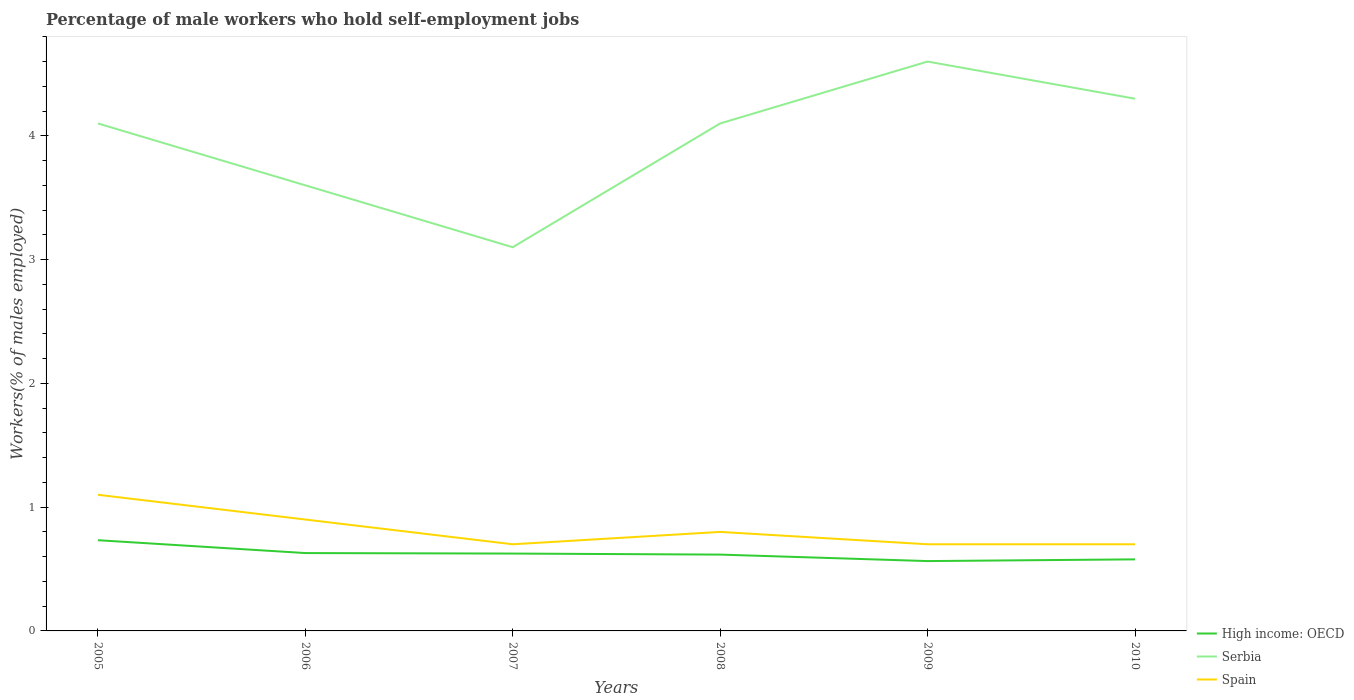How many different coloured lines are there?
Ensure brevity in your answer.  3. Does the line corresponding to Serbia intersect with the line corresponding to Spain?
Keep it short and to the point. No. Across all years, what is the maximum percentage of self-employed male workers in High income: OECD?
Your answer should be compact. 0.56. In which year was the percentage of self-employed male workers in High income: OECD maximum?
Offer a very short reply. 2009. What is the total percentage of self-employed male workers in Serbia in the graph?
Make the answer very short. -0.5. What is the difference between the highest and the second highest percentage of self-employed male workers in Spain?
Give a very brief answer. 0.4. What is the difference between the highest and the lowest percentage of self-employed male workers in High income: OECD?
Make the answer very short. 3. How many lines are there?
Your answer should be very brief. 3. What is the difference between two consecutive major ticks on the Y-axis?
Give a very brief answer. 1. Are the values on the major ticks of Y-axis written in scientific E-notation?
Provide a short and direct response. No. Does the graph contain any zero values?
Offer a very short reply. No. How many legend labels are there?
Make the answer very short. 3. What is the title of the graph?
Your answer should be very brief. Percentage of male workers who hold self-employment jobs. What is the label or title of the X-axis?
Keep it short and to the point. Years. What is the label or title of the Y-axis?
Offer a very short reply. Workers(% of males employed). What is the Workers(% of males employed) of High income: OECD in 2005?
Your answer should be compact. 0.73. What is the Workers(% of males employed) in Serbia in 2005?
Give a very brief answer. 4.1. What is the Workers(% of males employed) of Spain in 2005?
Provide a short and direct response. 1.1. What is the Workers(% of males employed) in High income: OECD in 2006?
Your answer should be very brief. 0.63. What is the Workers(% of males employed) in Serbia in 2006?
Offer a very short reply. 3.6. What is the Workers(% of males employed) in Spain in 2006?
Offer a very short reply. 0.9. What is the Workers(% of males employed) in High income: OECD in 2007?
Your answer should be compact. 0.62. What is the Workers(% of males employed) of Serbia in 2007?
Ensure brevity in your answer.  3.1. What is the Workers(% of males employed) of Spain in 2007?
Your response must be concise. 0.7. What is the Workers(% of males employed) in High income: OECD in 2008?
Your answer should be compact. 0.62. What is the Workers(% of males employed) of Serbia in 2008?
Make the answer very short. 4.1. What is the Workers(% of males employed) of Spain in 2008?
Provide a short and direct response. 0.8. What is the Workers(% of males employed) of High income: OECD in 2009?
Your answer should be very brief. 0.56. What is the Workers(% of males employed) in Serbia in 2009?
Offer a terse response. 4.6. What is the Workers(% of males employed) of Spain in 2009?
Your answer should be compact. 0.7. What is the Workers(% of males employed) of High income: OECD in 2010?
Ensure brevity in your answer.  0.58. What is the Workers(% of males employed) in Serbia in 2010?
Provide a short and direct response. 4.3. What is the Workers(% of males employed) of Spain in 2010?
Make the answer very short. 0.7. Across all years, what is the maximum Workers(% of males employed) in High income: OECD?
Your answer should be compact. 0.73. Across all years, what is the maximum Workers(% of males employed) in Serbia?
Your answer should be very brief. 4.6. Across all years, what is the maximum Workers(% of males employed) of Spain?
Give a very brief answer. 1.1. Across all years, what is the minimum Workers(% of males employed) of High income: OECD?
Offer a terse response. 0.56. Across all years, what is the minimum Workers(% of males employed) in Serbia?
Your response must be concise. 3.1. Across all years, what is the minimum Workers(% of males employed) in Spain?
Make the answer very short. 0.7. What is the total Workers(% of males employed) of High income: OECD in the graph?
Your answer should be compact. 3.75. What is the total Workers(% of males employed) in Serbia in the graph?
Offer a terse response. 23.8. What is the total Workers(% of males employed) in Spain in the graph?
Make the answer very short. 4.9. What is the difference between the Workers(% of males employed) in High income: OECD in 2005 and that in 2006?
Give a very brief answer. 0.1. What is the difference between the Workers(% of males employed) of Serbia in 2005 and that in 2006?
Your answer should be compact. 0.5. What is the difference between the Workers(% of males employed) of High income: OECD in 2005 and that in 2007?
Your answer should be very brief. 0.11. What is the difference between the Workers(% of males employed) of Serbia in 2005 and that in 2007?
Your answer should be very brief. 1. What is the difference between the Workers(% of males employed) in Spain in 2005 and that in 2007?
Give a very brief answer. 0.4. What is the difference between the Workers(% of males employed) of High income: OECD in 2005 and that in 2008?
Your answer should be very brief. 0.12. What is the difference between the Workers(% of males employed) of High income: OECD in 2005 and that in 2009?
Keep it short and to the point. 0.17. What is the difference between the Workers(% of males employed) in Serbia in 2005 and that in 2009?
Keep it short and to the point. -0.5. What is the difference between the Workers(% of males employed) in Spain in 2005 and that in 2009?
Offer a very short reply. 0.4. What is the difference between the Workers(% of males employed) in High income: OECD in 2005 and that in 2010?
Your response must be concise. 0.15. What is the difference between the Workers(% of males employed) in Spain in 2005 and that in 2010?
Offer a terse response. 0.4. What is the difference between the Workers(% of males employed) in High income: OECD in 2006 and that in 2007?
Offer a terse response. 0. What is the difference between the Workers(% of males employed) of Serbia in 2006 and that in 2007?
Offer a very short reply. 0.5. What is the difference between the Workers(% of males employed) in High income: OECD in 2006 and that in 2008?
Your answer should be very brief. 0.01. What is the difference between the Workers(% of males employed) in Serbia in 2006 and that in 2008?
Provide a short and direct response. -0.5. What is the difference between the Workers(% of males employed) of Spain in 2006 and that in 2008?
Give a very brief answer. 0.1. What is the difference between the Workers(% of males employed) of High income: OECD in 2006 and that in 2009?
Offer a terse response. 0.06. What is the difference between the Workers(% of males employed) in Serbia in 2006 and that in 2009?
Give a very brief answer. -1. What is the difference between the Workers(% of males employed) in Spain in 2006 and that in 2009?
Provide a succinct answer. 0.2. What is the difference between the Workers(% of males employed) in High income: OECD in 2006 and that in 2010?
Your answer should be compact. 0.05. What is the difference between the Workers(% of males employed) in High income: OECD in 2007 and that in 2008?
Provide a short and direct response. 0.01. What is the difference between the Workers(% of males employed) of Serbia in 2007 and that in 2008?
Your answer should be compact. -1. What is the difference between the Workers(% of males employed) in High income: OECD in 2007 and that in 2009?
Provide a succinct answer. 0.06. What is the difference between the Workers(% of males employed) in Serbia in 2007 and that in 2009?
Give a very brief answer. -1.5. What is the difference between the Workers(% of males employed) in High income: OECD in 2007 and that in 2010?
Provide a short and direct response. 0.05. What is the difference between the Workers(% of males employed) in Serbia in 2007 and that in 2010?
Make the answer very short. -1.2. What is the difference between the Workers(% of males employed) in Spain in 2007 and that in 2010?
Offer a terse response. 0. What is the difference between the Workers(% of males employed) of High income: OECD in 2008 and that in 2009?
Keep it short and to the point. 0.05. What is the difference between the Workers(% of males employed) in Serbia in 2008 and that in 2009?
Your answer should be very brief. -0.5. What is the difference between the Workers(% of males employed) of Spain in 2008 and that in 2009?
Your answer should be very brief. 0.1. What is the difference between the Workers(% of males employed) in High income: OECD in 2008 and that in 2010?
Give a very brief answer. 0.04. What is the difference between the Workers(% of males employed) of Spain in 2008 and that in 2010?
Provide a short and direct response. 0.1. What is the difference between the Workers(% of males employed) of High income: OECD in 2009 and that in 2010?
Offer a terse response. -0.01. What is the difference between the Workers(% of males employed) of Serbia in 2009 and that in 2010?
Your answer should be very brief. 0.3. What is the difference between the Workers(% of males employed) of Spain in 2009 and that in 2010?
Make the answer very short. 0. What is the difference between the Workers(% of males employed) of High income: OECD in 2005 and the Workers(% of males employed) of Serbia in 2006?
Your answer should be compact. -2.87. What is the difference between the Workers(% of males employed) of High income: OECD in 2005 and the Workers(% of males employed) of Spain in 2006?
Your response must be concise. -0.17. What is the difference between the Workers(% of males employed) in Serbia in 2005 and the Workers(% of males employed) in Spain in 2006?
Provide a short and direct response. 3.2. What is the difference between the Workers(% of males employed) of High income: OECD in 2005 and the Workers(% of males employed) of Serbia in 2007?
Offer a very short reply. -2.37. What is the difference between the Workers(% of males employed) of High income: OECD in 2005 and the Workers(% of males employed) of Spain in 2007?
Your answer should be compact. 0.03. What is the difference between the Workers(% of males employed) in High income: OECD in 2005 and the Workers(% of males employed) in Serbia in 2008?
Your response must be concise. -3.37. What is the difference between the Workers(% of males employed) in High income: OECD in 2005 and the Workers(% of males employed) in Spain in 2008?
Your response must be concise. -0.07. What is the difference between the Workers(% of males employed) in High income: OECD in 2005 and the Workers(% of males employed) in Serbia in 2009?
Make the answer very short. -3.87. What is the difference between the Workers(% of males employed) in High income: OECD in 2005 and the Workers(% of males employed) in Spain in 2009?
Ensure brevity in your answer.  0.03. What is the difference between the Workers(% of males employed) in Serbia in 2005 and the Workers(% of males employed) in Spain in 2009?
Keep it short and to the point. 3.4. What is the difference between the Workers(% of males employed) of High income: OECD in 2005 and the Workers(% of males employed) of Serbia in 2010?
Provide a succinct answer. -3.57. What is the difference between the Workers(% of males employed) in High income: OECD in 2005 and the Workers(% of males employed) in Spain in 2010?
Your response must be concise. 0.03. What is the difference between the Workers(% of males employed) in Serbia in 2005 and the Workers(% of males employed) in Spain in 2010?
Provide a short and direct response. 3.4. What is the difference between the Workers(% of males employed) of High income: OECD in 2006 and the Workers(% of males employed) of Serbia in 2007?
Your answer should be compact. -2.47. What is the difference between the Workers(% of males employed) of High income: OECD in 2006 and the Workers(% of males employed) of Spain in 2007?
Make the answer very short. -0.07. What is the difference between the Workers(% of males employed) of Serbia in 2006 and the Workers(% of males employed) of Spain in 2007?
Provide a short and direct response. 2.9. What is the difference between the Workers(% of males employed) in High income: OECD in 2006 and the Workers(% of males employed) in Serbia in 2008?
Offer a terse response. -3.47. What is the difference between the Workers(% of males employed) in High income: OECD in 2006 and the Workers(% of males employed) in Spain in 2008?
Your response must be concise. -0.17. What is the difference between the Workers(% of males employed) in Serbia in 2006 and the Workers(% of males employed) in Spain in 2008?
Provide a succinct answer. 2.8. What is the difference between the Workers(% of males employed) of High income: OECD in 2006 and the Workers(% of males employed) of Serbia in 2009?
Your response must be concise. -3.97. What is the difference between the Workers(% of males employed) of High income: OECD in 2006 and the Workers(% of males employed) of Spain in 2009?
Offer a very short reply. -0.07. What is the difference between the Workers(% of males employed) in Serbia in 2006 and the Workers(% of males employed) in Spain in 2009?
Give a very brief answer. 2.9. What is the difference between the Workers(% of males employed) of High income: OECD in 2006 and the Workers(% of males employed) of Serbia in 2010?
Make the answer very short. -3.67. What is the difference between the Workers(% of males employed) of High income: OECD in 2006 and the Workers(% of males employed) of Spain in 2010?
Your answer should be compact. -0.07. What is the difference between the Workers(% of males employed) in Serbia in 2006 and the Workers(% of males employed) in Spain in 2010?
Offer a terse response. 2.9. What is the difference between the Workers(% of males employed) in High income: OECD in 2007 and the Workers(% of males employed) in Serbia in 2008?
Make the answer very short. -3.48. What is the difference between the Workers(% of males employed) of High income: OECD in 2007 and the Workers(% of males employed) of Spain in 2008?
Give a very brief answer. -0.17. What is the difference between the Workers(% of males employed) of Serbia in 2007 and the Workers(% of males employed) of Spain in 2008?
Give a very brief answer. 2.3. What is the difference between the Workers(% of males employed) of High income: OECD in 2007 and the Workers(% of males employed) of Serbia in 2009?
Offer a terse response. -3.98. What is the difference between the Workers(% of males employed) in High income: OECD in 2007 and the Workers(% of males employed) in Spain in 2009?
Give a very brief answer. -0.07. What is the difference between the Workers(% of males employed) of High income: OECD in 2007 and the Workers(% of males employed) of Serbia in 2010?
Your response must be concise. -3.67. What is the difference between the Workers(% of males employed) in High income: OECD in 2007 and the Workers(% of males employed) in Spain in 2010?
Your answer should be very brief. -0.07. What is the difference between the Workers(% of males employed) in Serbia in 2007 and the Workers(% of males employed) in Spain in 2010?
Your answer should be very brief. 2.4. What is the difference between the Workers(% of males employed) of High income: OECD in 2008 and the Workers(% of males employed) of Serbia in 2009?
Make the answer very short. -3.98. What is the difference between the Workers(% of males employed) in High income: OECD in 2008 and the Workers(% of males employed) in Spain in 2009?
Offer a terse response. -0.08. What is the difference between the Workers(% of males employed) in High income: OECD in 2008 and the Workers(% of males employed) in Serbia in 2010?
Keep it short and to the point. -3.68. What is the difference between the Workers(% of males employed) in High income: OECD in 2008 and the Workers(% of males employed) in Spain in 2010?
Offer a terse response. -0.08. What is the difference between the Workers(% of males employed) of High income: OECD in 2009 and the Workers(% of males employed) of Serbia in 2010?
Provide a short and direct response. -3.74. What is the difference between the Workers(% of males employed) in High income: OECD in 2009 and the Workers(% of males employed) in Spain in 2010?
Your answer should be very brief. -0.14. What is the average Workers(% of males employed) in High income: OECD per year?
Provide a succinct answer. 0.62. What is the average Workers(% of males employed) of Serbia per year?
Provide a succinct answer. 3.97. What is the average Workers(% of males employed) of Spain per year?
Offer a terse response. 0.82. In the year 2005, what is the difference between the Workers(% of males employed) of High income: OECD and Workers(% of males employed) of Serbia?
Offer a terse response. -3.37. In the year 2005, what is the difference between the Workers(% of males employed) of High income: OECD and Workers(% of males employed) of Spain?
Keep it short and to the point. -0.37. In the year 2006, what is the difference between the Workers(% of males employed) of High income: OECD and Workers(% of males employed) of Serbia?
Ensure brevity in your answer.  -2.97. In the year 2006, what is the difference between the Workers(% of males employed) in High income: OECD and Workers(% of males employed) in Spain?
Keep it short and to the point. -0.27. In the year 2007, what is the difference between the Workers(% of males employed) of High income: OECD and Workers(% of males employed) of Serbia?
Give a very brief answer. -2.48. In the year 2007, what is the difference between the Workers(% of males employed) in High income: OECD and Workers(% of males employed) in Spain?
Your answer should be compact. -0.07. In the year 2007, what is the difference between the Workers(% of males employed) of Serbia and Workers(% of males employed) of Spain?
Ensure brevity in your answer.  2.4. In the year 2008, what is the difference between the Workers(% of males employed) in High income: OECD and Workers(% of males employed) in Serbia?
Make the answer very short. -3.48. In the year 2008, what is the difference between the Workers(% of males employed) of High income: OECD and Workers(% of males employed) of Spain?
Ensure brevity in your answer.  -0.18. In the year 2008, what is the difference between the Workers(% of males employed) in Serbia and Workers(% of males employed) in Spain?
Your response must be concise. 3.3. In the year 2009, what is the difference between the Workers(% of males employed) in High income: OECD and Workers(% of males employed) in Serbia?
Your answer should be very brief. -4.04. In the year 2009, what is the difference between the Workers(% of males employed) of High income: OECD and Workers(% of males employed) of Spain?
Provide a succinct answer. -0.14. In the year 2009, what is the difference between the Workers(% of males employed) of Serbia and Workers(% of males employed) of Spain?
Offer a very short reply. 3.9. In the year 2010, what is the difference between the Workers(% of males employed) of High income: OECD and Workers(% of males employed) of Serbia?
Ensure brevity in your answer.  -3.72. In the year 2010, what is the difference between the Workers(% of males employed) in High income: OECD and Workers(% of males employed) in Spain?
Provide a succinct answer. -0.12. In the year 2010, what is the difference between the Workers(% of males employed) in Serbia and Workers(% of males employed) in Spain?
Make the answer very short. 3.6. What is the ratio of the Workers(% of males employed) in High income: OECD in 2005 to that in 2006?
Offer a terse response. 1.17. What is the ratio of the Workers(% of males employed) of Serbia in 2005 to that in 2006?
Give a very brief answer. 1.14. What is the ratio of the Workers(% of males employed) in Spain in 2005 to that in 2006?
Keep it short and to the point. 1.22. What is the ratio of the Workers(% of males employed) in High income: OECD in 2005 to that in 2007?
Ensure brevity in your answer.  1.17. What is the ratio of the Workers(% of males employed) of Serbia in 2005 to that in 2007?
Give a very brief answer. 1.32. What is the ratio of the Workers(% of males employed) of Spain in 2005 to that in 2007?
Make the answer very short. 1.57. What is the ratio of the Workers(% of males employed) of High income: OECD in 2005 to that in 2008?
Give a very brief answer. 1.19. What is the ratio of the Workers(% of males employed) in Serbia in 2005 to that in 2008?
Give a very brief answer. 1. What is the ratio of the Workers(% of males employed) in Spain in 2005 to that in 2008?
Offer a very short reply. 1.38. What is the ratio of the Workers(% of males employed) in High income: OECD in 2005 to that in 2009?
Your answer should be compact. 1.3. What is the ratio of the Workers(% of males employed) of Serbia in 2005 to that in 2009?
Provide a short and direct response. 0.89. What is the ratio of the Workers(% of males employed) in Spain in 2005 to that in 2009?
Offer a very short reply. 1.57. What is the ratio of the Workers(% of males employed) of High income: OECD in 2005 to that in 2010?
Provide a short and direct response. 1.27. What is the ratio of the Workers(% of males employed) of Serbia in 2005 to that in 2010?
Offer a very short reply. 0.95. What is the ratio of the Workers(% of males employed) in Spain in 2005 to that in 2010?
Offer a terse response. 1.57. What is the ratio of the Workers(% of males employed) of Serbia in 2006 to that in 2007?
Provide a short and direct response. 1.16. What is the ratio of the Workers(% of males employed) in Spain in 2006 to that in 2007?
Your response must be concise. 1.29. What is the ratio of the Workers(% of males employed) in High income: OECD in 2006 to that in 2008?
Ensure brevity in your answer.  1.02. What is the ratio of the Workers(% of males employed) of Serbia in 2006 to that in 2008?
Your answer should be compact. 0.88. What is the ratio of the Workers(% of males employed) of Spain in 2006 to that in 2008?
Offer a very short reply. 1.12. What is the ratio of the Workers(% of males employed) in High income: OECD in 2006 to that in 2009?
Make the answer very short. 1.11. What is the ratio of the Workers(% of males employed) in Serbia in 2006 to that in 2009?
Offer a terse response. 0.78. What is the ratio of the Workers(% of males employed) of High income: OECD in 2006 to that in 2010?
Provide a short and direct response. 1.09. What is the ratio of the Workers(% of males employed) in Serbia in 2006 to that in 2010?
Ensure brevity in your answer.  0.84. What is the ratio of the Workers(% of males employed) of Spain in 2006 to that in 2010?
Provide a short and direct response. 1.29. What is the ratio of the Workers(% of males employed) in High income: OECD in 2007 to that in 2008?
Your answer should be compact. 1.01. What is the ratio of the Workers(% of males employed) in Serbia in 2007 to that in 2008?
Provide a short and direct response. 0.76. What is the ratio of the Workers(% of males employed) of Spain in 2007 to that in 2008?
Offer a very short reply. 0.88. What is the ratio of the Workers(% of males employed) of High income: OECD in 2007 to that in 2009?
Keep it short and to the point. 1.11. What is the ratio of the Workers(% of males employed) in Serbia in 2007 to that in 2009?
Make the answer very short. 0.67. What is the ratio of the Workers(% of males employed) of High income: OECD in 2007 to that in 2010?
Provide a succinct answer. 1.08. What is the ratio of the Workers(% of males employed) in Serbia in 2007 to that in 2010?
Offer a very short reply. 0.72. What is the ratio of the Workers(% of males employed) of High income: OECD in 2008 to that in 2009?
Give a very brief answer. 1.09. What is the ratio of the Workers(% of males employed) of Serbia in 2008 to that in 2009?
Offer a terse response. 0.89. What is the ratio of the Workers(% of males employed) in High income: OECD in 2008 to that in 2010?
Your answer should be compact. 1.07. What is the ratio of the Workers(% of males employed) in Serbia in 2008 to that in 2010?
Your answer should be compact. 0.95. What is the ratio of the Workers(% of males employed) in Spain in 2008 to that in 2010?
Your answer should be very brief. 1.14. What is the ratio of the Workers(% of males employed) in High income: OECD in 2009 to that in 2010?
Offer a terse response. 0.98. What is the ratio of the Workers(% of males employed) of Serbia in 2009 to that in 2010?
Keep it short and to the point. 1.07. What is the ratio of the Workers(% of males employed) of Spain in 2009 to that in 2010?
Offer a terse response. 1. What is the difference between the highest and the second highest Workers(% of males employed) of High income: OECD?
Offer a terse response. 0.1. What is the difference between the highest and the second highest Workers(% of males employed) in Serbia?
Provide a succinct answer. 0.3. What is the difference between the highest and the lowest Workers(% of males employed) of High income: OECD?
Provide a succinct answer. 0.17. What is the difference between the highest and the lowest Workers(% of males employed) in Serbia?
Ensure brevity in your answer.  1.5. 